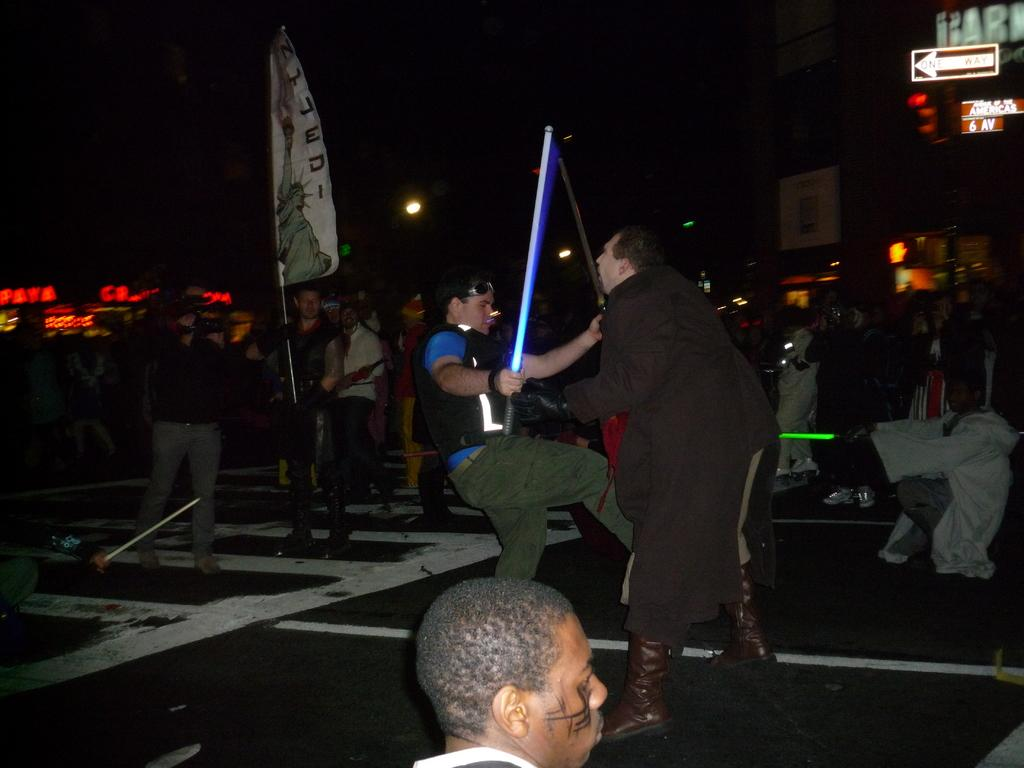How many people are in the image? There is a group of people in the image. What is one person in the group doing? One person is holding a flag. What objects can be seen in the image besides the people? There are boards, lights, and a building visible in the image. How would you describe the lighting conditions in the image? The background of the image is dark. What song is being sung by the beggar in the image? There is no beggar present in the image, and therefore no song can be heard or seen. What type of feather can be seen on the building in the image? There is no feather visible on the building in the image. 